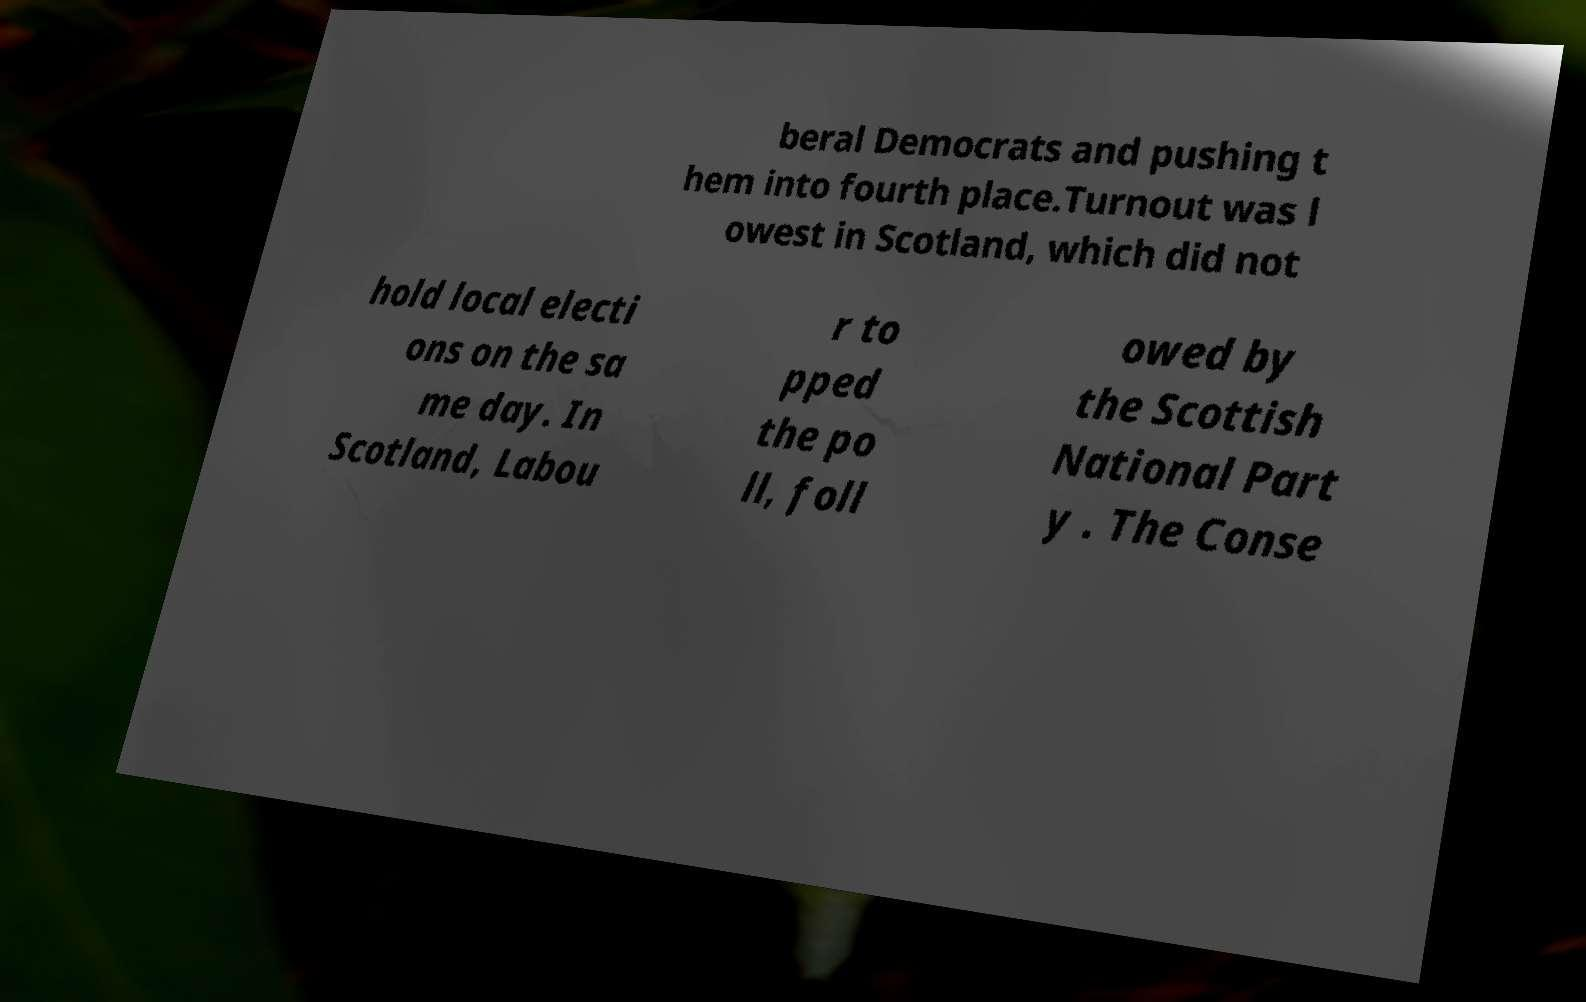What messages or text are displayed in this image? I need them in a readable, typed format. beral Democrats and pushing t hem into fourth place.Turnout was l owest in Scotland, which did not hold local electi ons on the sa me day. In Scotland, Labou r to pped the po ll, foll owed by the Scottish National Part y . The Conse 